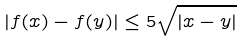Convert formula to latex. <formula><loc_0><loc_0><loc_500><loc_500>| f ( x ) - f ( y ) | \leq 5 \sqrt { | x - y | }</formula> 